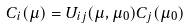Convert formula to latex. <formula><loc_0><loc_0><loc_500><loc_500>C _ { i } ( \mu ) = U _ { i j } ( \mu , \mu _ { 0 } ) C _ { j } ( \mu _ { 0 } )</formula> 